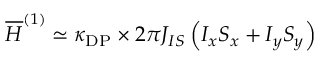<formula> <loc_0><loc_0><loc_500><loc_500>\overline { H } ^ { ( 1 ) } \simeq \kappa _ { D P } \times 2 \pi J _ { I S } \left ( I _ { x } S _ { x } + I _ { y } S _ { y } \right )</formula> 